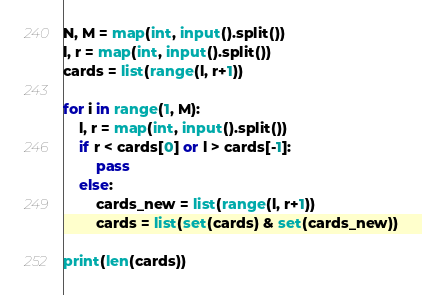Convert code to text. <code><loc_0><loc_0><loc_500><loc_500><_Python_>N, M = map(int, input().split())
l, r = map(int, input().split())
cards = list(range(l, r+1))

for i in range(1, M):
    l, r = map(int, input().split())
    if r < cards[0] or l > cards[-1]:
        pass
    else:
        cards_new = list(range(l, r+1))
        cards = list(set(cards) & set(cards_new))

print(len(cards))</code> 